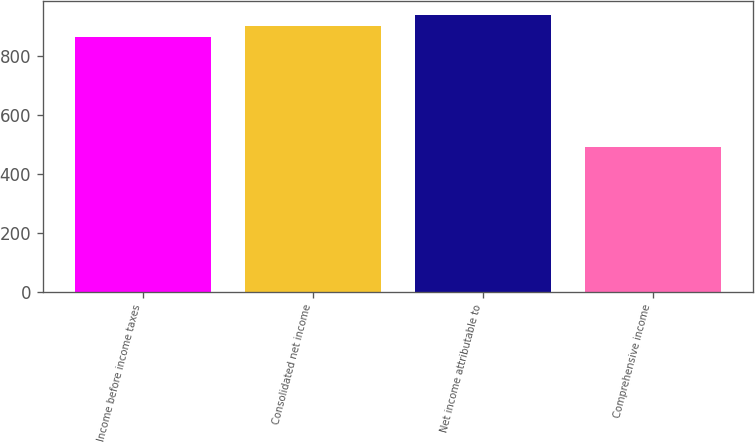<chart> <loc_0><loc_0><loc_500><loc_500><bar_chart><fcel>Income before income taxes<fcel>Consolidated net income<fcel>Net income attributable to<fcel>Comprehensive income<nl><fcel>862.9<fcel>900.29<fcel>937.68<fcel>489<nl></chart> 